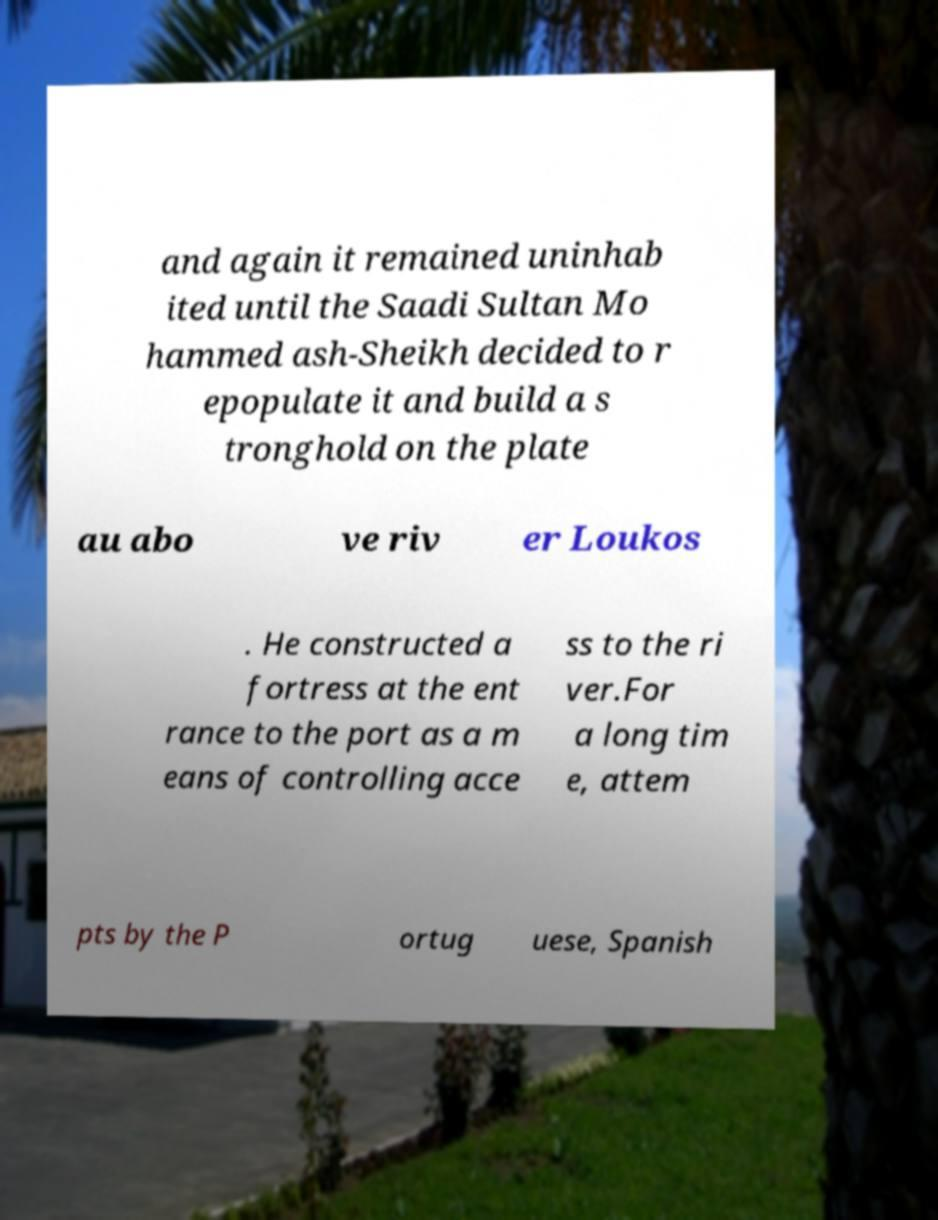Could you assist in decoding the text presented in this image and type it out clearly? and again it remained uninhab ited until the Saadi Sultan Mo hammed ash-Sheikh decided to r epopulate it and build a s tronghold on the plate au abo ve riv er Loukos . He constructed a fortress at the ent rance to the port as a m eans of controlling acce ss to the ri ver.For a long tim e, attem pts by the P ortug uese, Spanish 